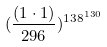Convert formula to latex. <formula><loc_0><loc_0><loc_500><loc_500>( \frac { ( 1 \cdot 1 ) } { 2 9 6 } ) ^ { 1 3 8 ^ { 1 3 0 } }</formula> 